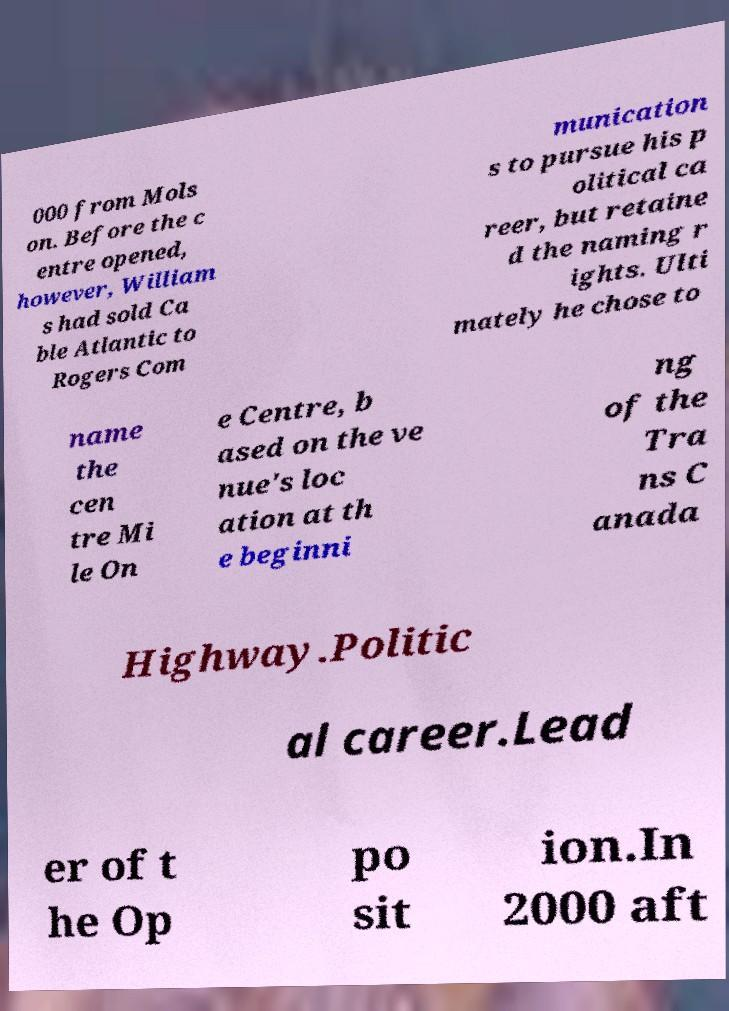Please read and relay the text visible in this image. What does it say? 000 from Mols on. Before the c entre opened, however, William s had sold Ca ble Atlantic to Rogers Com munication s to pursue his p olitical ca reer, but retaine d the naming r ights. Ulti mately he chose to name the cen tre Mi le On e Centre, b ased on the ve nue's loc ation at th e beginni ng of the Tra ns C anada Highway.Politic al career.Lead er of t he Op po sit ion.In 2000 aft 